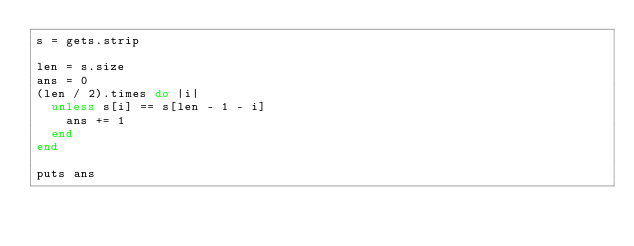<code> <loc_0><loc_0><loc_500><loc_500><_Ruby_>s = gets.strip

len = s.size
ans = 0
(len / 2).times do |i|
  unless s[i] == s[len - 1 - i]
    ans += 1
  end
end

puts ans
</code> 